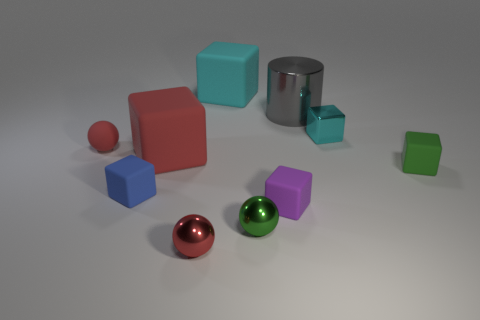Subtract all cyan blocks. How many blocks are left? 4 Subtract all big cyan rubber blocks. How many blocks are left? 5 Subtract all gray blocks. Subtract all brown spheres. How many blocks are left? 6 Subtract all spheres. How many objects are left? 7 Add 2 red matte balls. How many red matte balls are left? 3 Add 7 small blue rubber cylinders. How many small blue rubber cylinders exist? 7 Subtract 0 cyan spheres. How many objects are left? 10 Subtract all big brown metal cylinders. Subtract all cyan metal cubes. How many objects are left? 9 